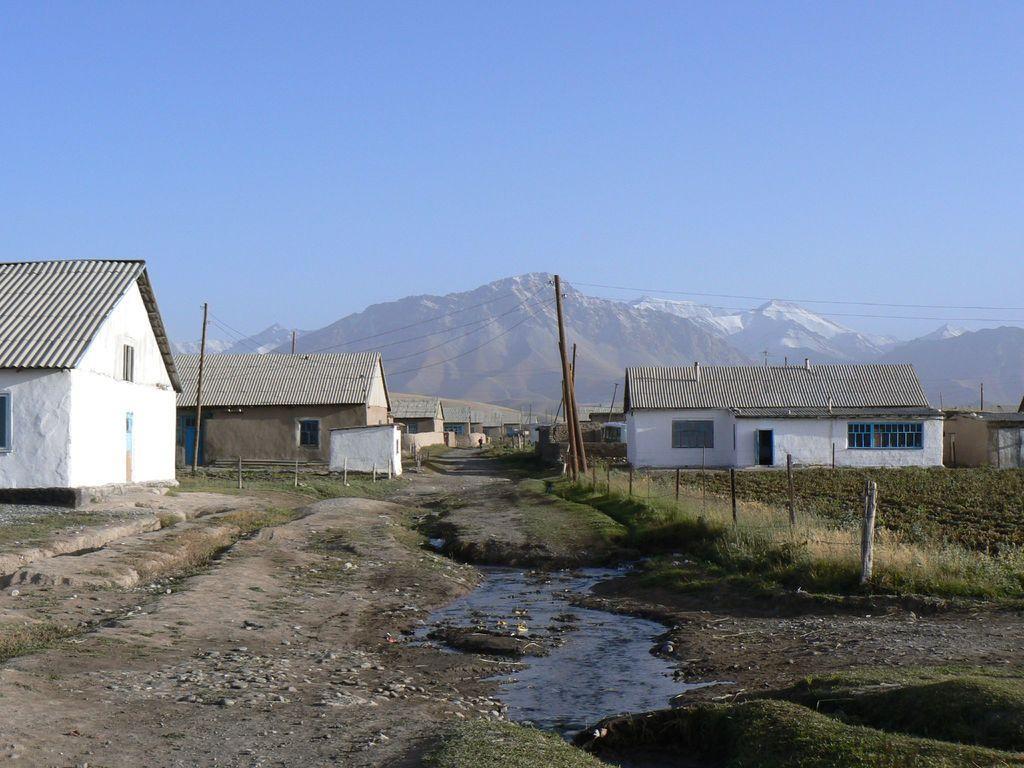Can you describe this image briefly? In this image, we can see houses, walls, windows, doors, poles, plants, grass, water and stones. Background we can see hills and sky. 